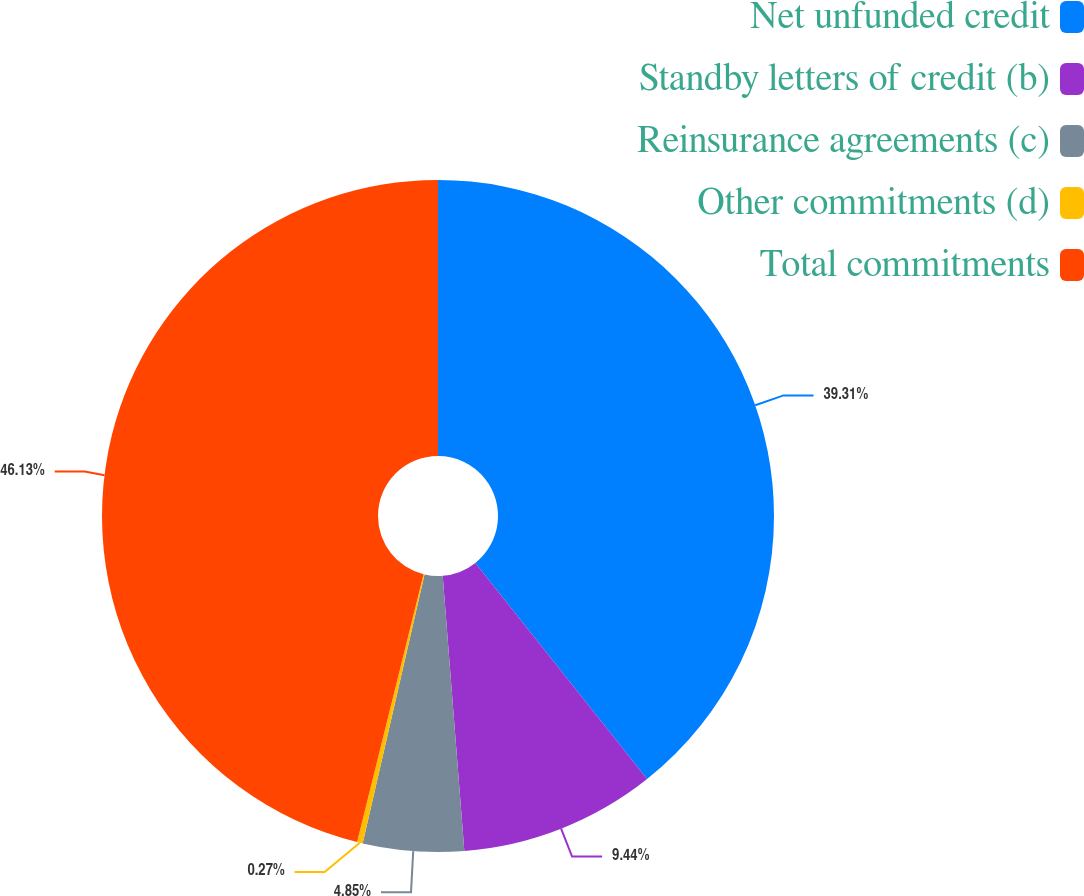Convert chart. <chart><loc_0><loc_0><loc_500><loc_500><pie_chart><fcel>Net unfunded credit<fcel>Standby letters of credit (b)<fcel>Reinsurance agreements (c)<fcel>Other commitments (d)<fcel>Total commitments<nl><fcel>39.31%<fcel>9.44%<fcel>4.85%<fcel>0.27%<fcel>46.13%<nl></chart> 